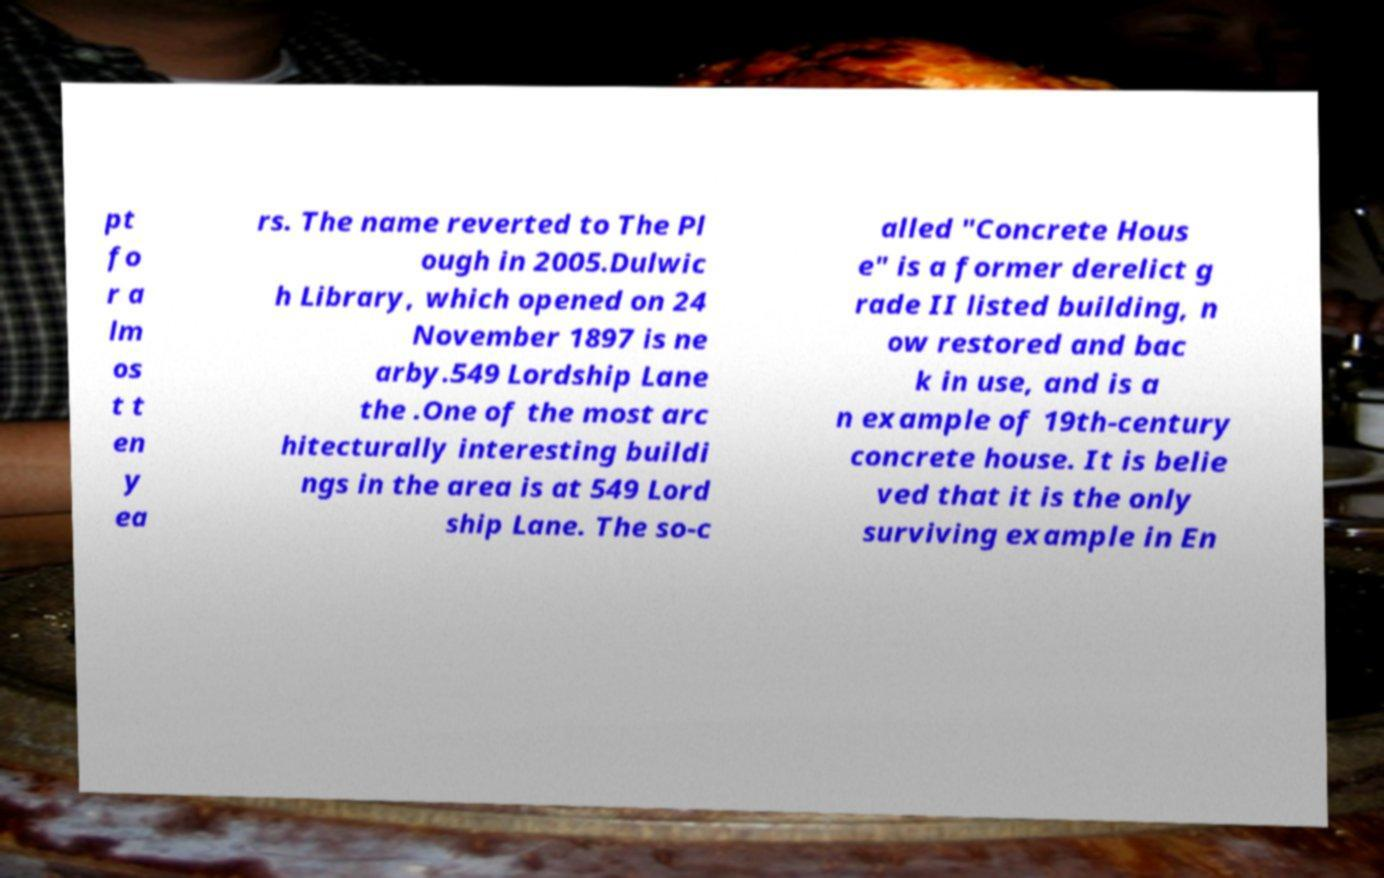What messages or text are displayed in this image? I need them in a readable, typed format. pt fo r a lm os t t en y ea rs. The name reverted to The Pl ough in 2005.Dulwic h Library, which opened on 24 November 1897 is ne arby.549 Lordship Lane the .One of the most arc hitecturally interesting buildi ngs in the area is at 549 Lord ship Lane. The so-c alled "Concrete Hous e" is a former derelict g rade II listed building, n ow restored and bac k in use, and is a n example of 19th-century concrete house. It is belie ved that it is the only surviving example in En 